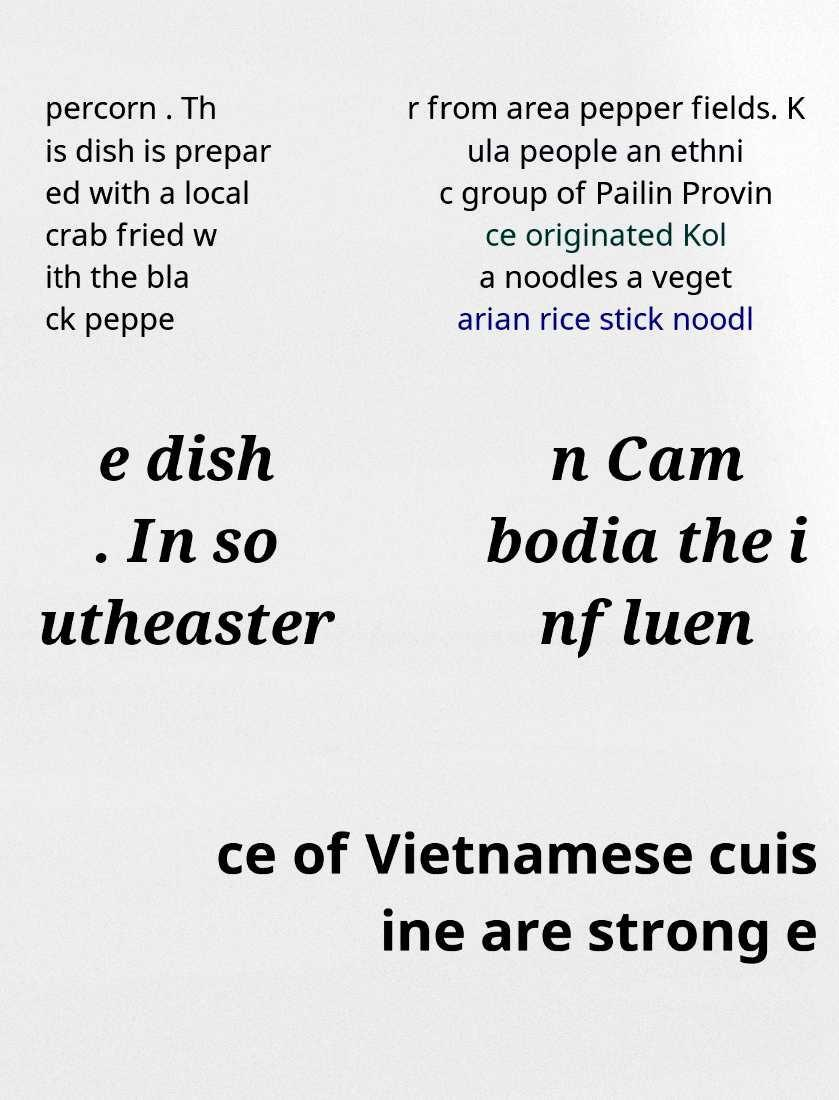Could you extract and type out the text from this image? percorn . Th is dish is prepar ed with a local crab fried w ith the bla ck peppe r from area pepper fields. K ula people an ethni c group of Pailin Provin ce originated Kol a noodles a veget arian rice stick noodl e dish . In so utheaster n Cam bodia the i nfluen ce of Vietnamese cuis ine are strong e 